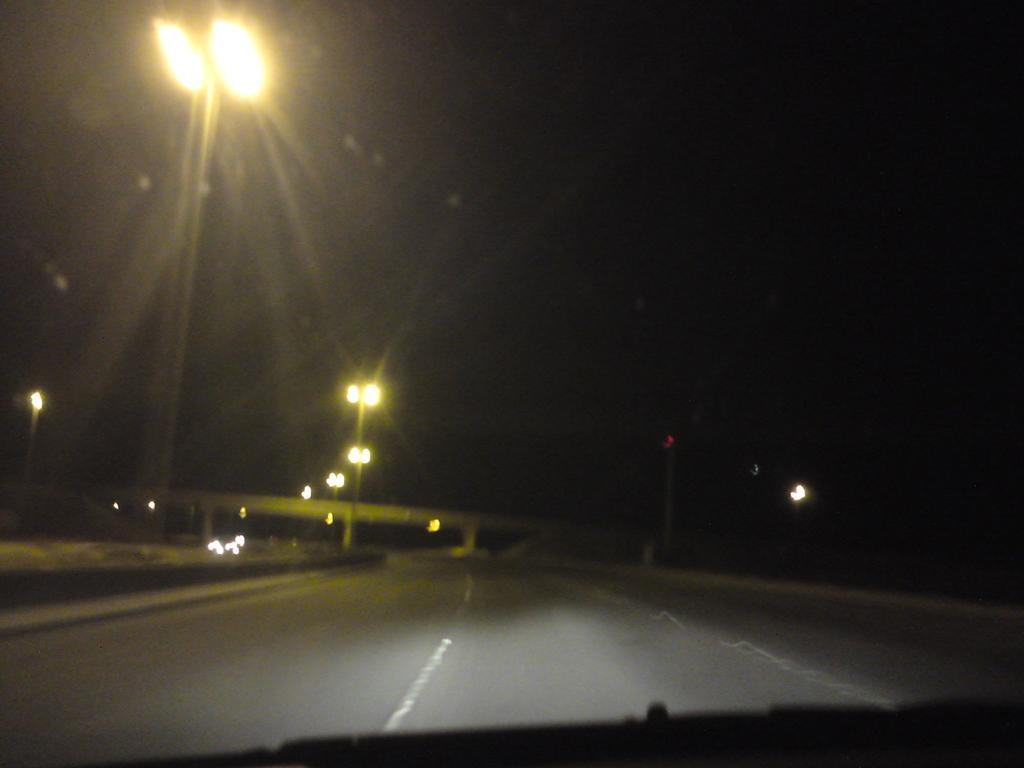Could you give a brief overview of what you see in this image? In this image there is road, there is pole, there are lightś attached to the pole, there is a bridge. 